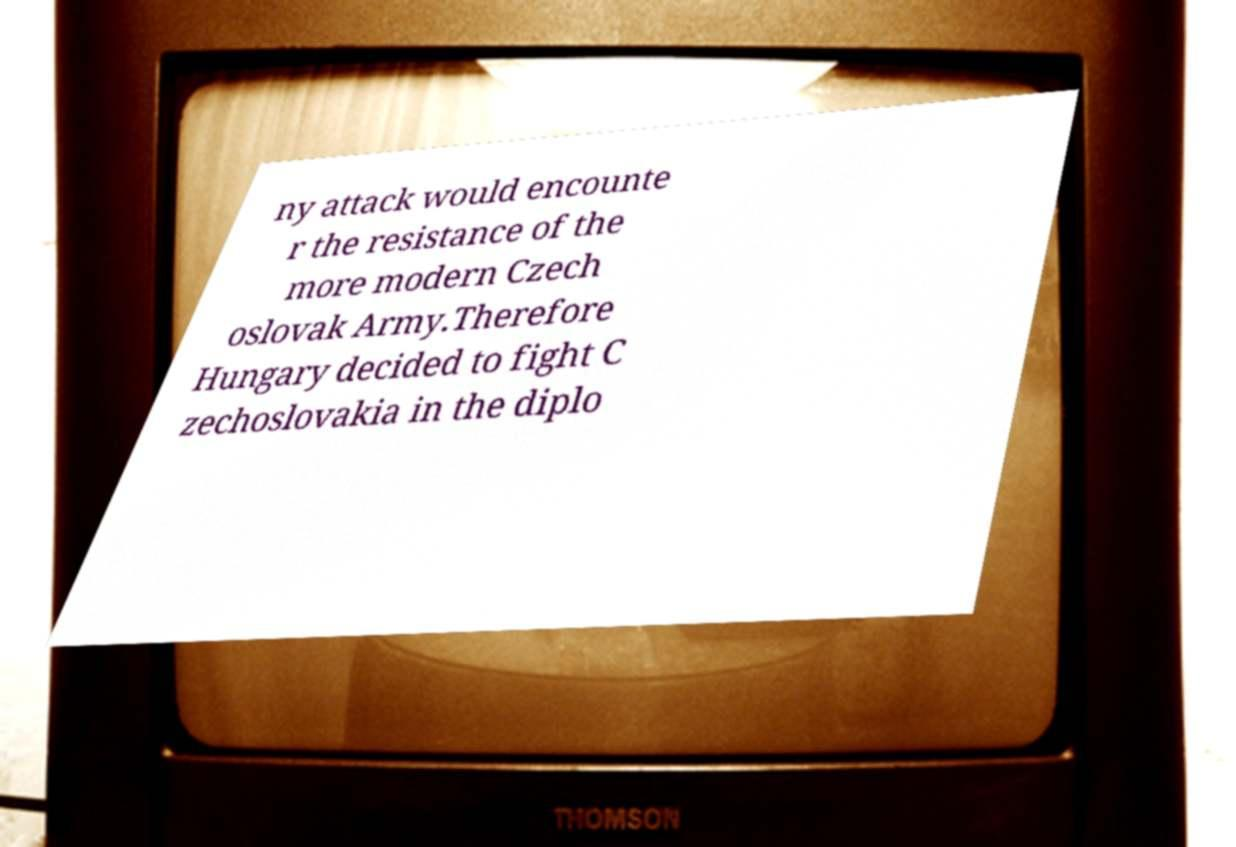For documentation purposes, I need the text within this image transcribed. Could you provide that? ny attack would encounte r the resistance of the more modern Czech oslovak Army.Therefore Hungary decided to fight C zechoslovakia in the diplo 